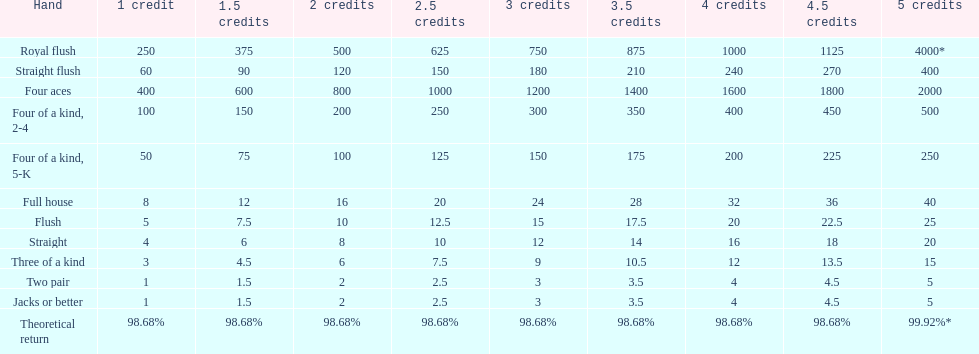The number of credits returned for a one credit bet on a royal flush are. 250. 